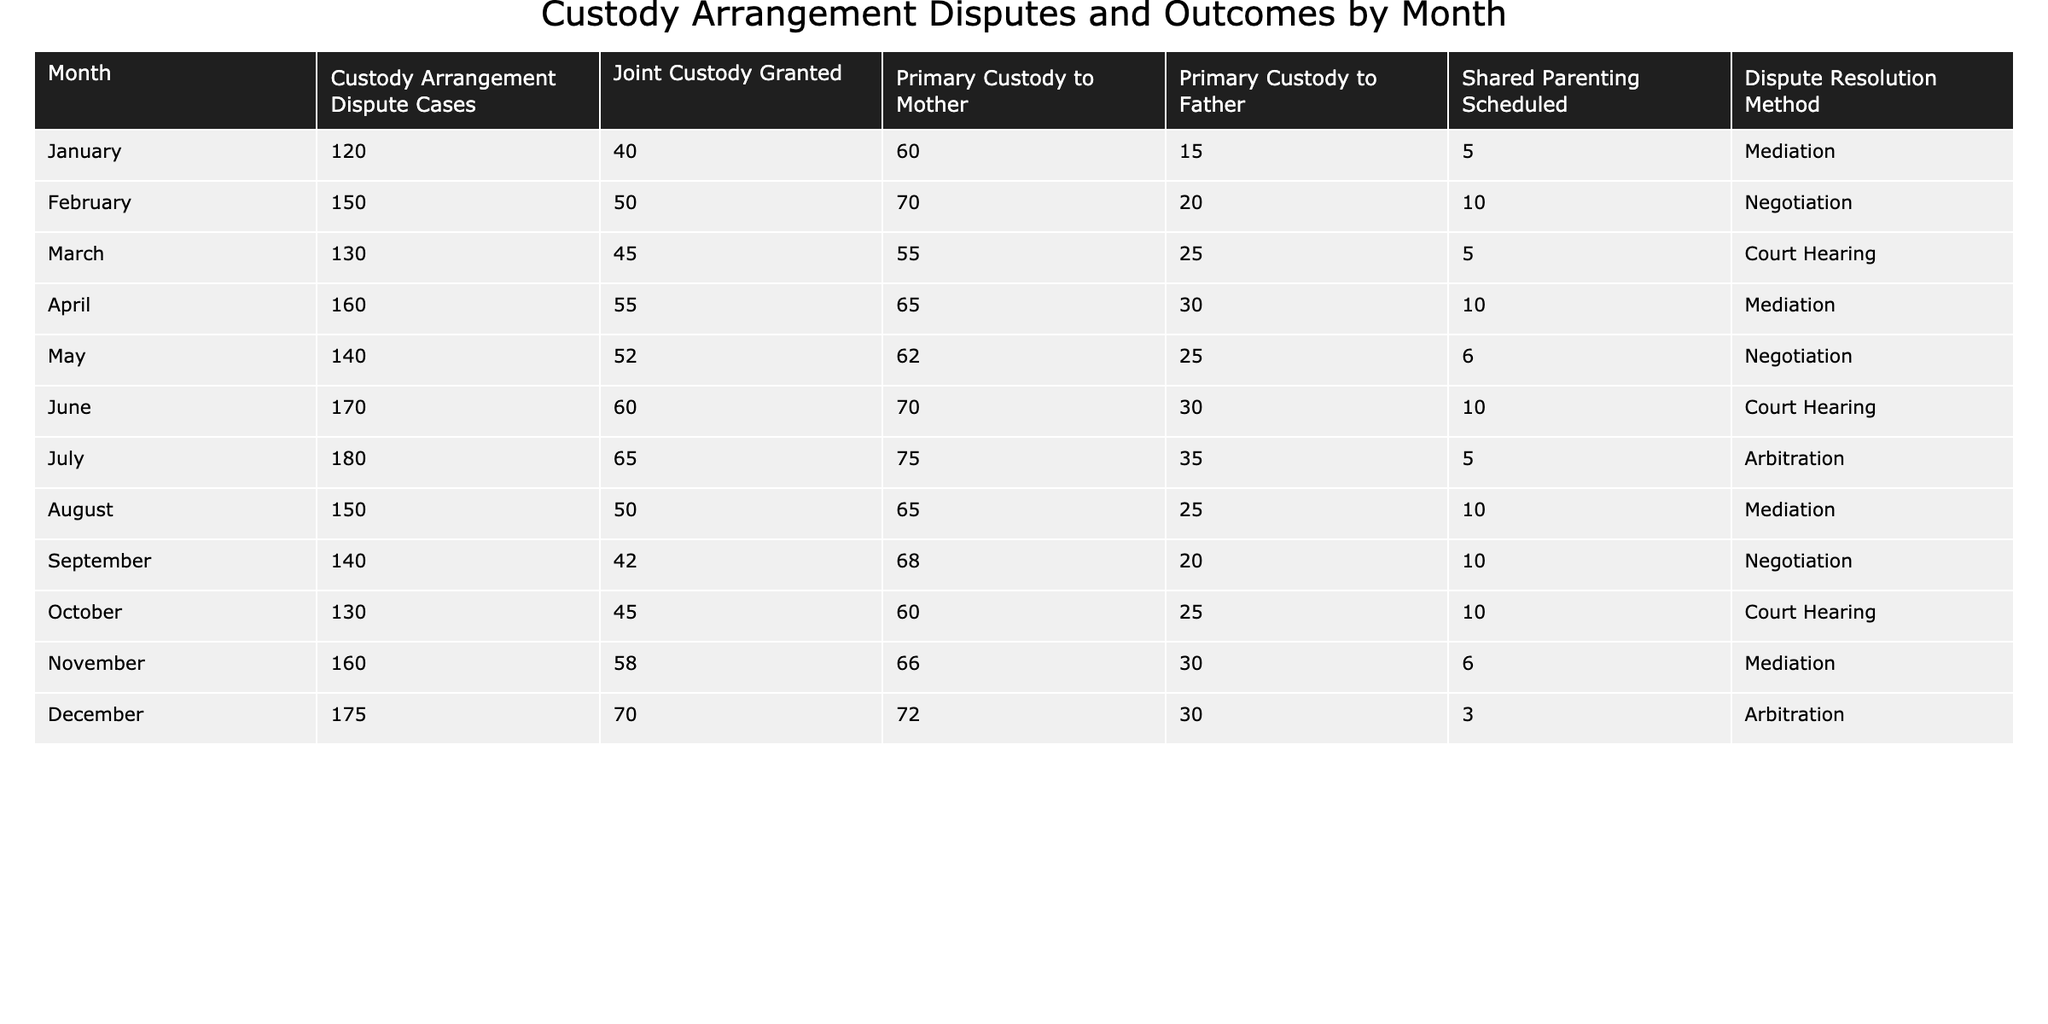What month had the highest number of custody arrangement dispute cases? By reviewing the table, we can see that July had the highest number of custody arrangement dispute cases, totaling 180.
Answer: July What was the total number of joint custody arrangements granted from January to March? We sum the joint custody granted for January (40), February (50), and March (45), which equals 40 + 50 + 45 = 135.
Answer: 135 In which month was shared parenting scheduled the least number of times? Looking at the shared parenting scheduled data, December has the lowest count at 3.
Answer: December True or False: More primary custody arrangements were granted to mothers than fathers in every month. We can check each month in the table. In January (60 to 15), February (70 to 20), March (55 to 25), April (65 to 30), May (62 to 25), June (70 to 30), July (75 to 35), August (65 to 25), September (68 to 20), October (60 to 25), November (66 to 30), and December (72 to 30), all show mothers with more custody except for January. Therefore, the statement is False.
Answer: False What is the average number of custody arrangement dispute cases per month over the year? To find the average, we add up all the dispute cases from January (120) to December (175), giving a total of 1,820 cases, and dividing this by 12 months yields 1,820 / 12 = 151.67. Therefore, the average is roughly 152.
Answer: 152 Which month had the same dispute resolution method as November? Looking at the dispute resolution methods, both April and November used mediation.
Answer: April What was the difference in the number of primary custody arrangements granted to mothers between June and August? We find the counts for June (70) and August (65) for mothers, then subtract: 70 - 65 = 5.
Answer: 5 In which month was the highest proportion of joint custody granted compared to the total dispute cases? We calculate the proportion for each month. The highest is in July, where 65 joint custody cases were granted out of 180 total disputes, giving a proportion of 65/180 ≈ 0.36 (or about 36%).
Answer: July How many more total custody arrangements were concluded through mediation than through court hearing in the last quarter of the year? In the last quarter (October, November, December), mediation resulted in (10 + 6 + 3 = 19) arrangements, while court hearings resulted in (10 + 30 = 40). The difference is 19 - 40 = -21, indicating court hearings had more.
Answer: 21 (more court hearings) 